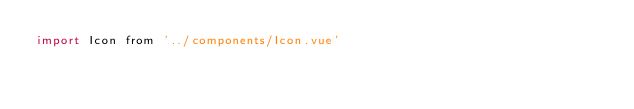<code> <loc_0><loc_0><loc_500><loc_500><_JavaScript_>import Icon from '../components/Icon.vue'
</code> 